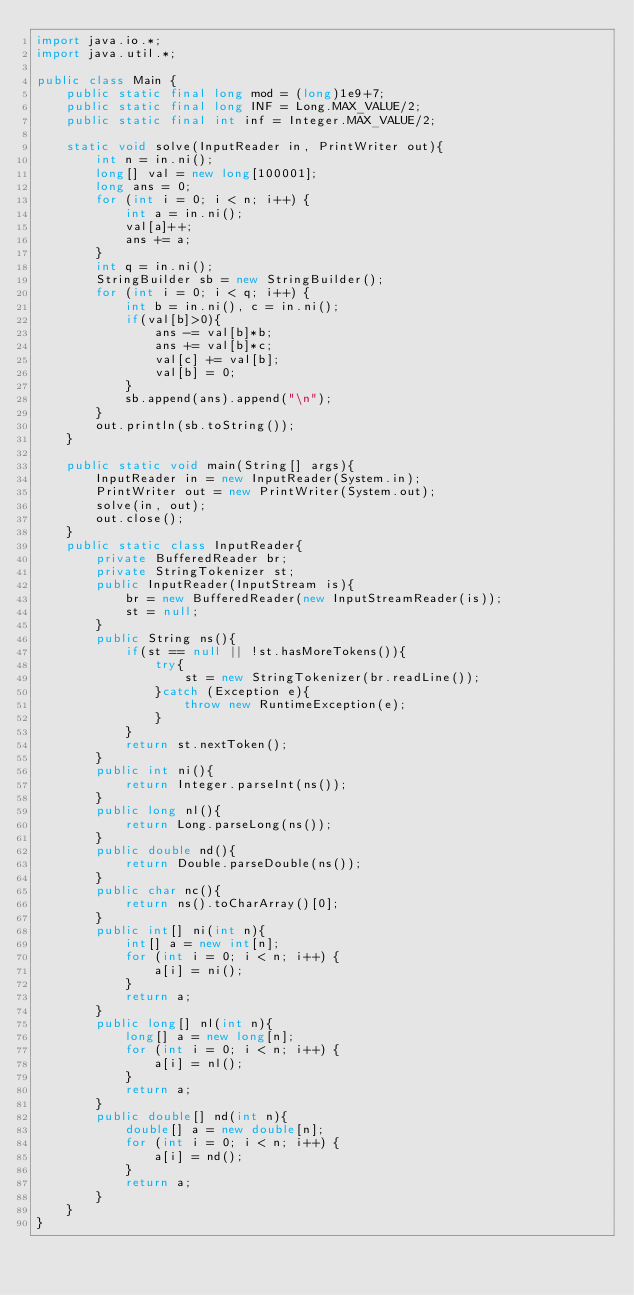Convert code to text. <code><loc_0><loc_0><loc_500><loc_500><_Java_>import java.io.*;
import java.util.*;

public class Main {
    public static final long mod = (long)1e9+7;
    public static final long INF = Long.MAX_VALUE/2;
    public static final int inf = Integer.MAX_VALUE/2;

    static void solve(InputReader in, PrintWriter out){
        int n = in.ni();
        long[] val = new long[100001];
        long ans = 0;
        for (int i = 0; i < n; i++) {
            int a = in.ni();
            val[a]++;
            ans += a;
        }
        int q = in.ni();
        StringBuilder sb = new StringBuilder();
        for (int i = 0; i < q; i++) {
            int b = in.ni(), c = in.ni();
            if(val[b]>0){
                ans -= val[b]*b;
                ans += val[b]*c;
                val[c] += val[b];
                val[b] = 0;
            }
            sb.append(ans).append("\n");
        }
        out.println(sb.toString());
    }

    public static void main(String[] args){
        InputReader in = new InputReader(System.in);
        PrintWriter out = new PrintWriter(System.out);
        solve(in, out);
        out.close();
    }
    public static class InputReader{
        private BufferedReader br;
        private StringTokenizer st;
        public InputReader(InputStream is){
            br = new BufferedReader(new InputStreamReader(is));
            st = null;
        }
        public String ns(){
            if(st == null || !st.hasMoreTokens()){
                try{
                    st = new StringTokenizer(br.readLine());
                }catch (Exception e){
                    throw new RuntimeException(e);
                }
            }
            return st.nextToken();
        }
        public int ni(){
            return Integer.parseInt(ns());
        }
        public long nl(){
            return Long.parseLong(ns());
        }
        public double nd(){
            return Double.parseDouble(ns());
        }
        public char nc(){
            return ns().toCharArray()[0];
        }
        public int[] ni(int n){
            int[] a = new int[n];
            for (int i = 0; i < n; i++) {
                a[i] = ni();
            }
            return a;
        }
        public long[] nl(int n){
            long[] a = new long[n];
            for (int i = 0; i < n; i++) {
                a[i] = nl();
            }
            return a;
        }
        public double[] nd(int n){
            double[] a = new double[n];
            for (int i = 0; i < n; i++) {
                a[i] = nd();
            }
            return a;
        }
    }
}</code> 